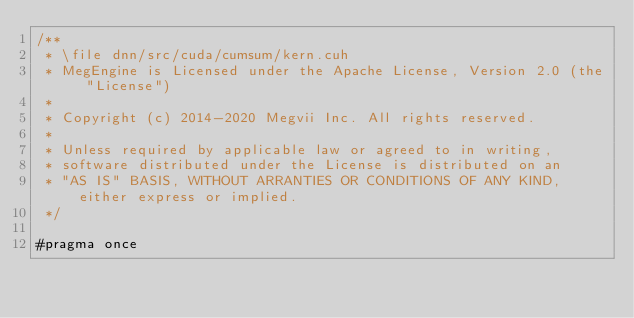Convert code to text. <code><loc_0><loc_0><loc_500><loc_500><_Cuda_>/**
 * \file dnn/src/cuda/cumsum/kern.cuh
 * MegEngine is Licensed under the Apache License, Version 2.0 (the "License")
 *
 * Copyright (c) 2014-2020 Megvii Inc. All rights reserved.
 *
 * Unless required by applicable law or agreed to in writing,
 * software distributed under the License is distributed on an
 * "AS IS" BASIS, WITHOUT ARRANTIES OR CONDITIONS OF ANY KIND, either express or implied.
 */

#pragma once
</code> 